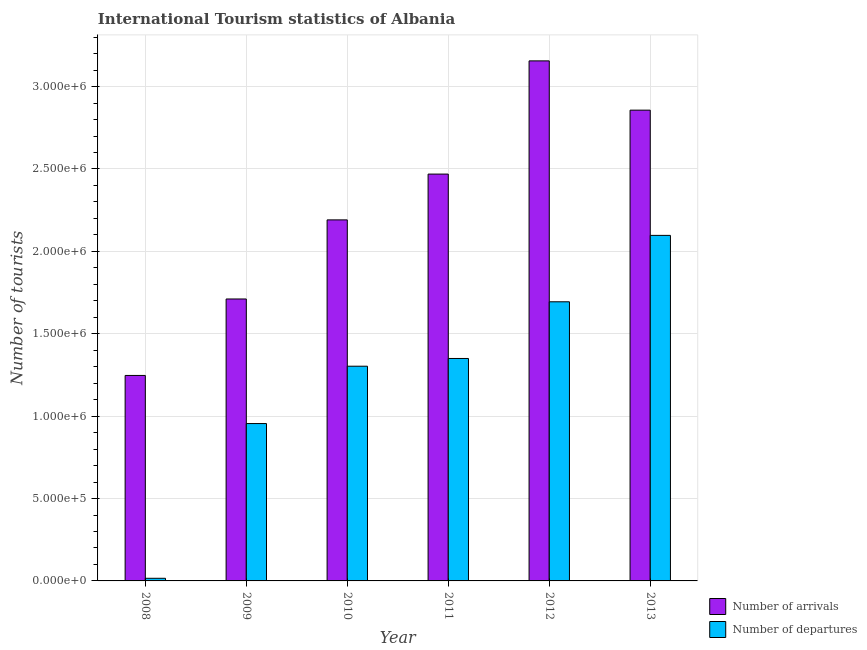Are the number of bars per tick equal to the number of legend labels?
Ensure brevity in your answer.  Yes. What is the label of the 1st group of bars from the left?
Make the answer very short. 2008. What is the number of tourist arrivals in 2009?
Provide a succinct answer. 1.71e+06. Across all years, what is the maximum number of tourist arrivals?
Your answer should be compact. 3.16e+06. Across all years, what is the minimum number of tourist arrivals?
Your answer should be very brief. 1.25e+06. In which year was the number of tourist departures maximum?
Offer a very short reply. 2013. In which year was the number of tourist departures minimum?
Ensure brevity in your answer.  2008. What is the total number of tourist arrivals in the graph?
Keep it short and to the point. 1.36e+07. What is the difference between the number of tourist arrivals in 2010 and that in 2013?
Keep it short and to the point. -6.66e+05. What is the difference between the number of tourist arrivals in 2012 and the number of tourist departures in 2010?
Give a very brief answer. 9.65e+05. What is the average number of tourist departures per year?
Provide a succinct answer. 1.24e+06. What is the ratio of the number of tourist departures in 2009 to that in 2012?
Your answer should be compact. 0.56. Is the number of tourist departures in 2010 less than that in 2012?
Provide a short and direct response. Yes. What is the difference between the highest and the second highest number of tourist departures?
Make the answer very short. 4.03e+05. What is the difference between the highest and the lowest number of tourist departures?
Ensure brevity in your answer.  2.08e+06. In how many years, is the number of tourist arrivals greater than the average number of tourist arrivals taken over all years?
Your response must be concise. 3. What does the 1st bar from the left in 2008 represents?
Offer a terse response. Number of arrivals. What does the 2nd bar from the right in 2008 represents?
Offer a terse response. Number of arrivals. Are all the bars in the graph horizontal?
Provide a succinct answer. No. How many years are there in the graph?
Give a very brief answer. 6. Does the graph contain any zero values?
Your answer should be very brief. No. How are the legend labels stacked?
Offer a terse response. Vertical. What is the title of the graph?
Provide a short and direct response. International Tourism statistics of Albania. Does "Investments" appear as one of the legend labels in the graph?
Offer a terse response. No. What is the label or title of the Y-axis?
Offer a very short reply. Number of tourists. What is the Number of tourists of Number of arrivals in 2008?
Your answer should be very brief. 1.25e+06. What is the Number of tourists in Number of departures in 2008?
Make the answer very short. 1.60e+04. What is the Number of tourists of Number of arrivals in 2009?
Provide a short and direct response. 1.71e+06. What is the Number of tourists in Number of departures in 2009?
Provide a succinct answer. 9.55e+05. What is the Number of tourists of Number of arrivals in 2010?
Your answer should be very brief. 2.19e+06. What is the Number of tourists in Number of departures in 2010?
Keep it short and to the point. 1.30e+06. What is the Number of tourists in Number of arrivals in 2011?
Give a very brief answer. 2.47e+06. What is the Number of tourists of Number of departures in 2011?
Your response must be concise. 1.35e+06. What is the Number of tourists in Number of arrivals in 2012?
Make the answer very short. 3.16e+06. What is the Number of tourists in Number of departures in 2012?
Provide a short and direct response. 1.69e+06. What is the Number of tourists in Number of arrivals in 2013?
Provide a short and direct response. 2.86e+06. What is the Number of tourists of Number of departures in 2013?
Offer a terse response. 2.10e+06. Across all years, what is the maximum Number of tourists in Number of arrivals?
Give a very brief answer. 3.16e+06. Across all years, what is the maximum Number of tourists in Number of departures?
Your answer should be compact. 2.10e+06. Across all years, what is the minimum Number of tourists in Number of arrivals?
Provide a succinct answer. 1.25e+06. Across all years, what is the minimum Number of tourists of Number of departures?
Give a very brief answer. 1.60e+04. What is the total Number of tourists in Number of arrivals in the graph?
Ensure brevity in your answer.  1.36e+07. What is the total Number of tourists in Number of departures in the graph?
Ensure brevity in your answer.  7.42e+06. What is the difference between the Number of tourists in Number of arrivals in 2008 and that in 2009?
Offer a very short reply. -4.64e+05. What is the difference between the Number of tourists in Number of departures in 2008 and that in 2009?
Make the answer very short. -9.39e+05. What is the difference between the Number of tourists of Number of arrivals in 2008 and that in 2010?
Provide a short and direct response. -9.44e+05. What is the difference between the Number of tourists of Number of departures in 2008 and that in 2010?
Your answer should be compact. -1.29e+06. What is the difference between the Number of tourists in Number of arrivals in 2008 and that in 2011?
Your answer should be very brief. -1.22e+06. What is the difference between the Number of tourists of Number of departures in 2008 and that in 2011?
Keep it short and to the point. -1.33e+06. What is the difference between the Number of tourists in Number of arrivals in 2008 and that in 2012?
Your answer should be compact. -1.91e+06. What is the difference between the Number of tourists in Number of departures in 2008 and that in 2012?
Give a very brief answer. -1.68e+06. What is the difference between the Number of tourists of Number of arrivals in 2008 and that in 2013?
Offer a terse response. -1.61e+06. What is the difference between the Number of tourists of Number of departures in 2008 and that in 2013?
Provide a succinct answer. -2.08e+06. What is the difference between the Number of tourists of Number of arrivals in 2009 and that in 2010?
Your answer should be compact. -4.80e+05. What is the difference between the Number of tourists in Number of departures in 2009 and that in 2010?
Make the answer very short. -3.48e+05. What is the difference between the Number of tourists in Number of arrivals in 2009 and that in 2011?
Ensure brevity in your answer.  -7.58e+05. What is the difference between the Number of tourists in Number of departures in 2009 and that in 2011?
Keep it short and to the point. -3.95e+05. What is the difference between the Number of tourists of Number of arrivals in 2009 and that in 2012?
Offer a very short reply. -1.44e+06. What is the difference between the Number of tourists in Number of departures in 2009 and that in 2012?
Ensure brevity in your answer.  -7.39e+05. What is the difference between the Number of tourists in Number of arrivals in 2009 and that in 2013?
Your answer should be very brief. -1.15e+06. What is the difference between the Number of tourists of Number of departures in 2009 and that in 2013?
Provide a succinct answer. -1.14e+06. What is the difference between the Number of tourists in Number of arrivals in 2010 and that in 2011?
Your answer should be compact. -2.78e+05. What is the difference between the Number of tourists in Number of departures in 2010 and that in 2011?
Provide a succinct answer. -4.70e+04. What is the difference between the Number of tourists of Number of arrivals in 2010 and that in 2012?
Ensure brevity in your answer.  -9.65e+05. What is the difference between the Number of tourists of Number of departures in 2010 and that in 2012?
Your answer should be very brief. -3.91e+05. What is the difference between the Number of tourists in Number of arrivals in 2010 and that in 2013?
Offer a very short reply. -6.66e+05. What is the difference between the Number of tourists in Number of departures in 2010 and that in 2013?
Offer a very short reply. -7.94e+05. What is the difference between the Number of tourists of Number of arrivals in 2011 and that in 2012?
Give a very brief answer. -6.87e+05. What is the difference between the Number of tourists of Number of departures in 2011 and that in 2012?
Your response must be concise. -3.44e+05. What is the difference between the Number of tourists in Number of arrivals in 2011 and that in 2013?
Provide a short and direct response. -3.88e+05. What is the difference between the Number of tourists in Number of departures in 2011 and that in 2013?
Your answer should be compact. -7.47e+05. What is the difference between the Number of tourists of Number of arrivals in 2012 and that in 2013?
Your response must be concise. 2.99e+05. What is the difference between the Number of tourists in Number of departures in 2012 and that in 2013?
Your answer should be compact. -4.03e+05. What is the difference between the Number of tourists in Number of arrivals in 2008 and the Number of tourists in Number of departures in 2009?
Provide a short and direct response. 2.92e+05. What is the difference between the Number of tourists in Number of arrivals in 2008 and the Number of tourists in Number of departures in 2010?
Your answer should be compact. -5.60e+04. What is the difference between the Number of tourists in Number of arrivals in 2008 and the Number of tourists in Number of departures in 2011?
Keep it short and to the point. -1.03e+05. What is the difference between the Number of tourists of Number of arrivals in 2008 and the Number of tourists of Number of departures in 2012?
Provide a short and direct response. -4.47e+05. What is the difference between the Number of tourists of Number of arrivals in 2008 and the Number of tourists of Number of departures in 2013?
Your response must be concise. -8.50e+05. What is the difference between the Number of tourists in Number of arrivals in 2009 and the Number of tourists in Number of departures in 2010?
Your answer should be very brief. 4.08e+05. What is the difference between the Number of tourists of Number of arrivals in 2009 and the Number of tourists of Number of departures in 2011?
Offer a very short reply. 3.61e+05. What is the difference between the Number of tourists in Number of arrivals in 2009 and the Number of tourists in Number of departures in 2012?
Ensure brevity in your answer.  1.70e+04. What is the difference between the Number of tourists in Number of arrivals in 2009 and the Number of tourists in Number of departures in 2013?
Provide a succinct answer. -3.86e+05. What is the difference between the Number of tourists of Number of arrivals in 2010 and the Number of tourists of Number of departures in 2011?
Ensure brevity in your answer.  8.41e+05. What is the difference between the Number of tourists in Number of arrivals in 2010 and the Number of tourists in Number of departures in 2012?
Make the answer very short. 4.97e+05. What is the difference between the Number of tourists in Number of arrivals in 2010 and the Number of tourists in Number of departures in 2013?
Your response must be concise. 9.40e+04. What is the difference between the Number of tourists in Number of arrivals in 2011 and the Number of tourists in Number of departures in 2012?
Ensure brevity in your answer.  7.75e+05. What is the difference between the Number of tourists of Number of arrivals in 2011 and the Number of tourists of Number of departures in 2013?
Offer a terse response. 3.72e+05. What is the difference between the Number of tourists of Number of arrivals in 2012 and the Number of tourists of Number of departures in 2013?
Offer a very short reply. 1.06e+06. What is the average Number of tourists of Number of arrivals per year?
Provide a succinct answer. 2.27e+06. What is the average Number of tourists in Number of departures per year?
Your answer should be compact. 1.24e+06. In the year 2008, what is the difference between the Number of tourists in Number of arrivals and Number of tourists in Number of departures?
Your answer should be compact. 1.23e+06. In the year 2009, what is the difference between the Number of tourists in Number of arrivals and Number of tourists in Number of departures?
Your answer should be very brief. 7.56e+05. In the year 2010, what is the difference between the Number of tourists in Number of arrivals and Number of tourists in Number of departures?
Keep it short and to the point. 8.88e+05. In the year 2011, what is the difference between the Number of tourists in Number of arrivals and Number of tourists in Number of departures?
Ensure brevity in your answer.  1.12e+06. In the year 2012, what is the difference between the Number of tourists of Number of arrivals and Number of tourists of Number of departures?
Make the answer very short. 1.46e+06. In the year 2013, what is the difference between the Number of tourists of Number of arrivals and Number of tourists of Number of departures?
Your answer should be compact. 7.60e+05. What is the ratio of the Number of tourists in Number of arrivals in 2008 to that in 2009?
Your answer should be compact. 0.73. What is the ratio of the Number of tourists of Number of departures in 2008 to that in 2009?
Provide a succinct answer. 0.02. What is the ratio of the Number of tourists of Number of arrivals in 2008 to that in 2010?
Your response must be concise. 0.57. What is the ratio of the Number of tourists of Number of departures in 2008 to that in 2010?
Provide a short and direct response. 0.01. What is the ratio of the Number of tourists in Number of arrivals in 2008 to that in 2011?
Provide a succinct answer. 0.51. What is the ratio of the Number of tourists of Number of departures in 2008 to that in 2011?
Your answer should be very brief. 0.01. What is the ratio of the Number of tourists in Number of arrivals in 2008 to that in 2012?
Offer a very short reply. 0.4. What is the ratio of the Number of tourists in Number of departures in 2008 to that in 2012?
Keep it short and to the point. 0.01. What is the ratio of the Number of tourists in Number of arrivals in 2008 to that in 2013?
Your answer should be compact. 0.44. What is the ratio of the Number of tourists in Number of departures in 2008 to that in 2013?
Your response must be concise. 0.01. What is the ratio of the Number of tourists in Number of arrivals in 2009 to that in 2010?
Ensure brevity in your answer.  0.78. What is the ratio of the Number of tourists in Number of departures in 2009 to that in 2010?
Offer a terse response. 0.73. What is the ratio of the Number of tourists in Number of arrivals in 2009 to that in 2011?
Ensure brevity in your answer.  0.69. What is the ratio of the Number of tourists in Number of departures in 2009 to that in 2011?
Your answer should be very brief. 0.71. What is the ratio of the Number of tourists of Number of arrivals in 2009 to that in 2012?
Offer a very short reply. 0.54. What is the ratio of the Number of tourists of Number of departures in 2009 to that in 2012?
Make the answer very short. 0.56. What is the ratio of the Number of tourists in Number of arrivals in 2009 to that in 2013?
Give a very brief answer. 0.6. What is the ratio of the Number of tourists in Number of departures in 2009 to that in 2013?
Make the answer very short. 0.46. What is the ratio of the Number of tourists of Number of arrivals in 2010 to that in 2011?
Give a very brief answer. 0.89. What is the ratio of the Number of tourists in Number of departures in 2010 to that in 2011?
Your answer should be very brief. 0.97. What is the ratio of the Number of tourists in Number of arrivals in 2010 to that in 2012?
Offer a terse response. 0.69. What is the ratio of the Number of tourists in Number of departures in 2010 to that in 2012?
Give a very brief answer. 0.77. What is the ratio of the Number of tourists in Number of arrivals in 2010 to that in 2013?
Your answer should be very brief. 0.77. What is the ratio of the Number of tourists in Number of departures in 2010 to that in 2013?
Provide a succinct answer. 0.62. What is the ratio of the Number of tourists in Number of arrivals in 2011 to that in 2012?
Offer a terse response. 0.78. What is the ratio of the Number of tourists of Number of departures in 2011 to that in 2012?
Offer a terse response. 0.8. What is the ratio of the Number of tourists of Number of arrivals in 2011 to that in 2013?
Offer a terse response. 0.86. What is the ratio of the Number of tourists of Number of departures in 2011 to that in 2013?
Make the answer very short. 0.64. What is the ratio of the Number of tourists in Number of arrivals in 2012 to that in 2013?
Keep it short and to the point. 1.1. What is the ratio of the Number of tourists in Number of departures in 2012 to that in 2013?
Keep it short and to the point. 0.81. What is the difference between the highest and the second highest Number of tourists of Number of arrivals?
Offer a very short reply. 2.99e+05. What is the difference between the highest and the second highest Number of tourists of Number of departures?
Your answer should be very brief. 4.03e+05. What is the difference between the highest and the lowest Number of tourists in Number of arrivals?
Give a very brief answer. 1.91e+06. What is the difference between the highest and the lowest Number of tourists of Number of departures?
Give a very brief answer. 2.08e+06. 